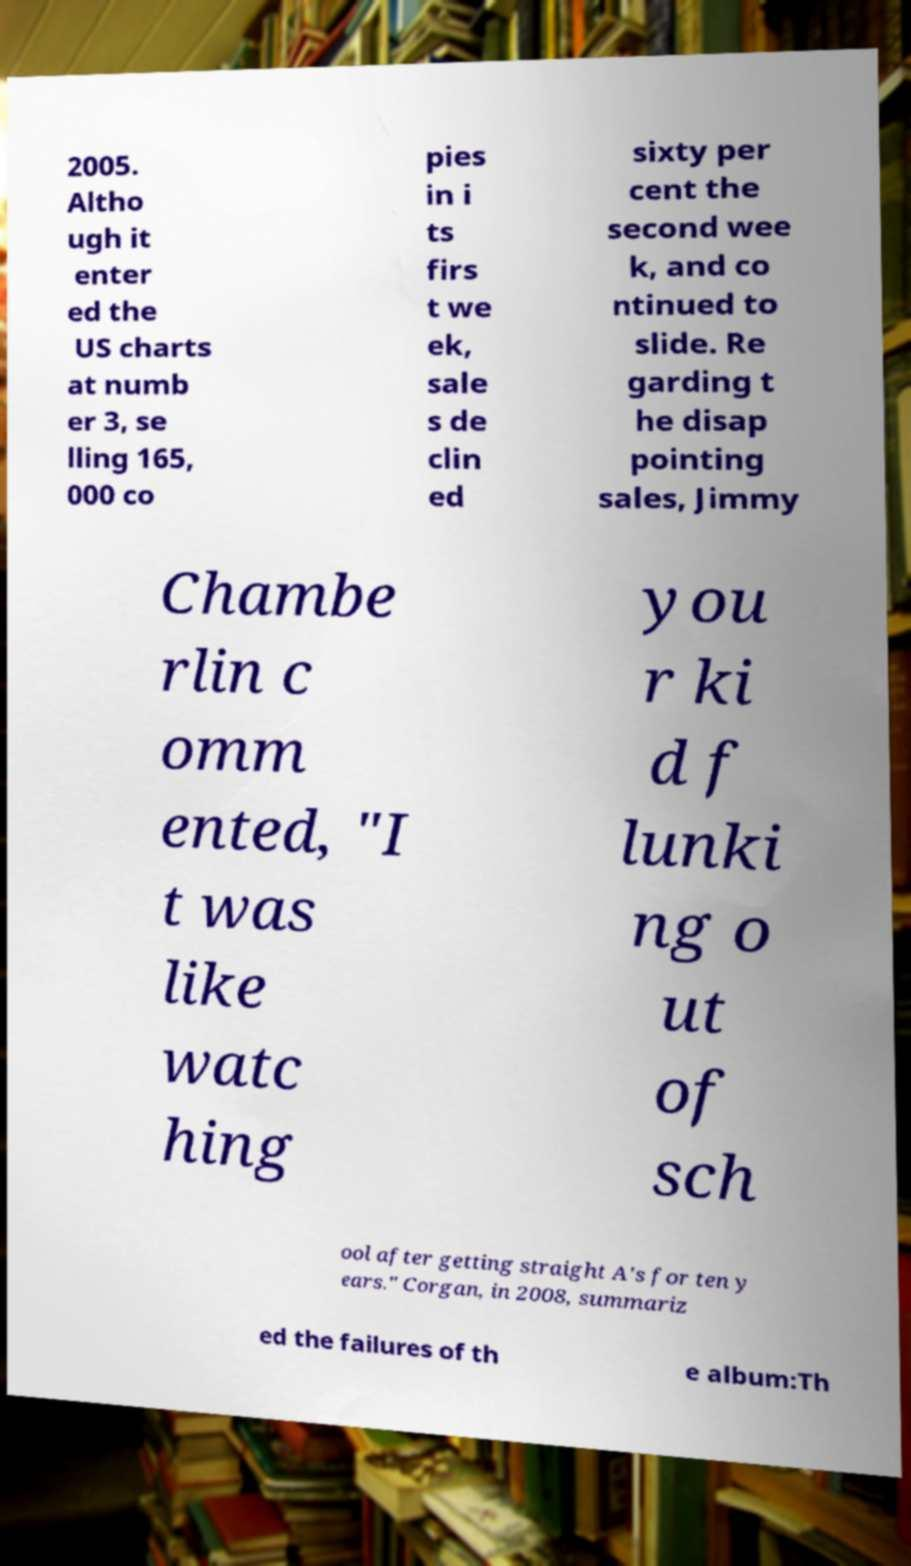Can you read and provide the text displayed in the image?This photo seems to have some interesting text. Can you extract and type it out for me? 2005. Altho ugh it enter ed the US charts at numb er 3, se lling 165, 000 co pies in i ts firs t we ek, sale s de clin ed sixty per cent the second wee k, and co ntinued to slide. Re garding t he disap pointing sales, Jimmy Chambe rlin c omm ented, "I t was like watc hing you r ki d f lunki ng o ut of sch ool after getting straight A's for ten y ears." Corgan, in 2008, summariz ed the failures of th e album:Th 